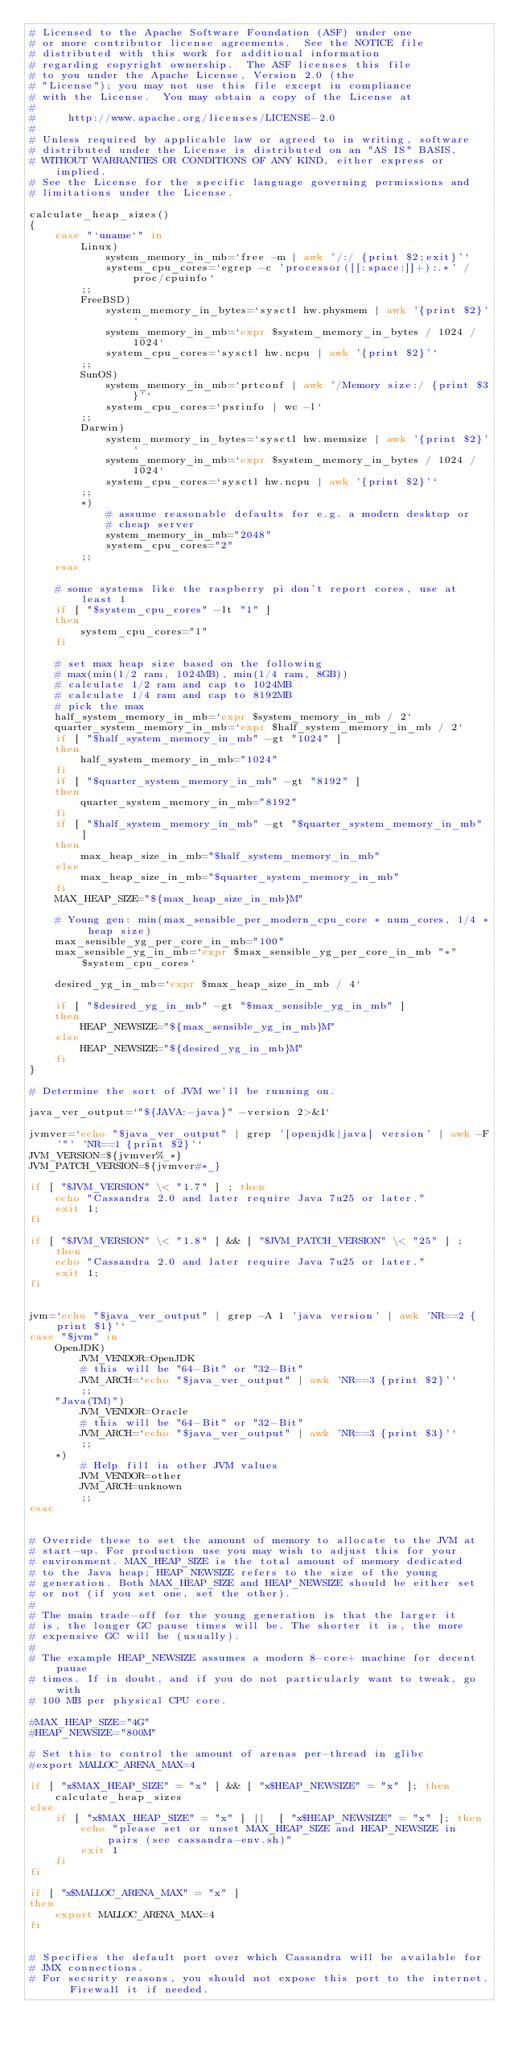Convert code to text. <code><loc_0><loc_0><loc_500><loc_500><_Bash_># Licensed to the Apache Software Foundation (ASF) under one
# or more contributor license agreements.  See the NOTICE file
# distributed with this work for additional information
# regarding copyright ownership.  The ASF licenses this file
# to you under the Apache License, Version 2.0 (the
# "License"); you may not use this file except in compliance
# with the License.  You may obtain a copy of the License at
#
#     http://www.apache.org/licenses/LICENSE-2.0
#
# Unless required by applicable law or agreed to in writing, software
# distributed under the License is distributed on an "AS IS" BASIS,
# WITHOUT WARRANTIES OR CONDITIONS OF ANY KIND, either express or implied.
# See the License for the specific language governing permissions and
# limitations under the License.

calculate_heap_sizes()
{
    case "`uname`" in
        Linux)
            system_memory_in_mb=`free -m | awk '/:/ {print $2;exit}'`
            system_cpu_cores=`egrep -c 'processor([[:space:]]+):.*' /proc/cpuinfo`
        ;;
        FreeBSD)
            system_memory_in_bytes=`sysctl hw.physmem | awk '{print $2}'`
            system_memory_in_mb=`expr $system_memory_in_bytes / 1024 / 1024`
            system_cpu_cores=`sysctl hw.ncpu | awk '{print $2}'`
        ;;
        SunOS)
            system_memory_in_mb=`prtconf | awk '/Memory size:/ {print $3}'`
            system_cpu_cores=`psrinfo | wc -l`
        ;;
        Darwin)
            system_memory_in_bytes=`sysctl hw.memsize | awk '{print $2}'`
            system_memory_in_mb=`expr $system_memory_in_bytes / 1024 / 1024`
            system_cpu_cores=`sysctl hw.ncpu | awk '{print $2}'`
        ;;
        *)
            # assume reasonable defaults for e.g. a modern desktop or
            # cheap server
            system_memory_in_mb="2048"
            system_cpu_cores="2"
        ;;
    esac

    # some systems like the raspberry pi don't report cores, use at least 1
    if [ "$system_cpu_cores" -lt "1" ]
    then
        system_cpu_cores="1"
    fi

    # set max heap size based on the following
    # max(min(1/2 ram, 1024MB), min(1/4 ram, 8GB))
    # calculate 1/2 ram and cap to 1024MB
    # calculate 1/4 ram and cap to 8192MB
    # pick the max
    half_system_memory_in_mb=`expr $system_memory_in_mb / 2`
    quarter_system_memory_in_mb=`expr $half_system_memory_in_mb / 2`
    if [ "$half_system_memory_in_mb" -gt "1024" ]
    then
        half_system_memory_in_mb="1024"
    fi
    if [ "$quarter_system_memory_in_mb" -gt "8192" ]
    then
        quarter_system_memory_in_mb="8192"
    fi
    if [ "$half_system_memory_in_mb" -gt "$quarter_system_memory_in_mb" ]
    then
        max_heap_size_in_mb="$half_system_memory_in_mb"
    else
        max_heap_size_in_mb="$quarter_system_memory_in_mb"
    fi
    MAX_HEAP_SIZE="${max_heap_size_in_mb}M"

    # Young gen: min(max_sensible_per_modern_cpu_core * num_cores, 1/4 * heap size)
    max_sensible_yg_per_core_in_mb="100"
    max_sensible_yg_in_mb=`expr $max_sensible_yg_per_core_in_mb "*" $system_cpu_cores`

    desired_yg_in_mb=`expr $max_heap_size_in_mb / 4`

    if [ "$desired_yg_in_mb" -gt "$max_sensible_yg_in_mb" ]
    then
        HEAP_NEWSIZE="${max_sensible_yg_in_mb}M"
    else
        HEAP_NEWSIZE="${desired_yg_in_mb}M"
    fi
}

# Determine the sort of JVM we'll be running on.

java_ver_output=`"${JAVA:-java}" -version 2>&1`

jvmver=`echo "$java_ver_output" | grep '[openjdk|java] version' | awk -F'"' 'NR==1 {print $2}'`
JVM_VERSION=${jvmver%_*}
JVM_PATCH_VERSION=${jvmver#*_}

if [ "$JVM_VERSION" \< "1.7" ] ; then
    echo "Cassandra 2.0 and later require Java 7u25 or later."
    exit 1;
fi

if [ "$JVM_VERSION" \< "1.8" ] && [ "$JVM_PATCH_VERSION" \< "25" ] ; then
    echo "Cassandra 2.0 and later require Java 7u25 or later."
    exit 1;
fi


jvm=`echo "$java_ver_output" | grep -A 1 'java version' | awk 'NR==2 {print $1}'`
case "$jvm" in
    OpenJDK)
        JVM_VENDOR=OpenJDK
        # this will be "64-Bit" or "32-Bit"
        JVM_ARCH=`echo "$java_ver_output" | awk 'NR==3 {print $2}'`
        ;;
    "Java(TM)")
        JVM_VENDOR=Oracle
        # this will be "64-Bit" or "32-Bit"
        JVM_ARCH=`echo "$java_ver_output" | awk 'NR==3 {print $3}'`
        ;;
    *)
        # Help fill in other JVM values
        JVM_VENDOR=other
        JVM_ARCH=unknown
        ;;
esac


# Override these to set the amount of memory to allocate to the JVM at
# start-up. For production use you may wish to adjust this for your
# environment. MAX_HEAP_SIZE is the total amount of memory dedicated
# to the Java heap; HEAP_NEWSIZE refers to the size of the young
# generation. Both MAX_HEAP_SIZE and HEAP_NEWSIZE should be either set
# or not (if you set one, set the other).
#
# The main trade-off for the young generation is that the larger it
# is, the longer GC pause times will be. The shorter it is, the more
# expensive GC will be (usually).
#
# The example HEAP_NEWSIZE assumes a modern 8-core+ machine for decent pause
# times. If in doubt, and if you do not particularly want to tweak, go with
# 100 MB per physical CPU core.

#MAX_HEAP_SIZE="4G"
#HEAP_NEWSIZE="800M"

# Set this to control the amount of arenas per-thread in glibc
#export MALLOC_ARENA_MAX=4

if [ "x$MAX_HEAP_SIZE" = "x" ] && [ "x$HEAP_NEWSIZE" = "x" ]; then
    calculate_heap_sizes
else
    if [ "x$MAX_HEAP_SIZE" = "x" ] ||  [ "x$HEAP_NEWSIZE" = "x" ]; then
        echo "please set or unset MAX_HEAP_SIZE and HEAP_NEWSIZE in pairs (see cassandra-env.sh)"
        exit 1
    fi
fi

if [ "x$MALLOC_ARENA_MAX" = "x" ]
then
    export MALLOC_ARENA_MAX=4
fi


# Specifies the default port over which Cassandra will be available for
# JMX connections.
# For security reasons, you should not expose this port to the internet.  Firewall it if needed.</code> 